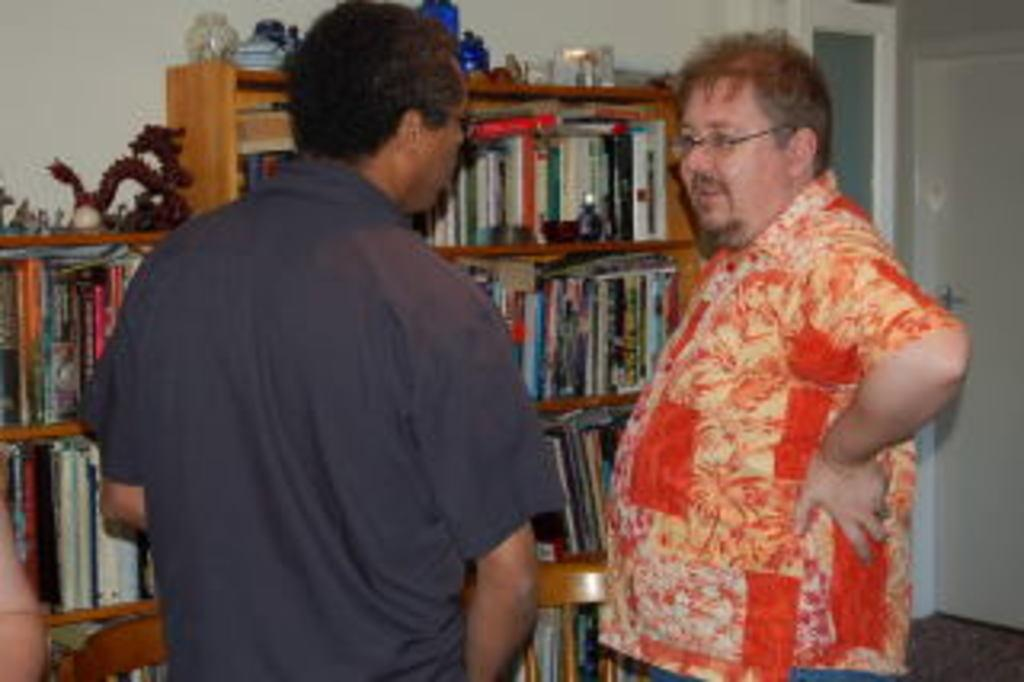How many people are present in the image? There are two persons in the image. What can be seen in the background of the image? There is a bookshelf in the image. Is there any architectural feature visible in the image? Yes, there is a door on a wall in the image. What type of story does the zephyr tell in the image? There is no zephyr or story present in the image. 